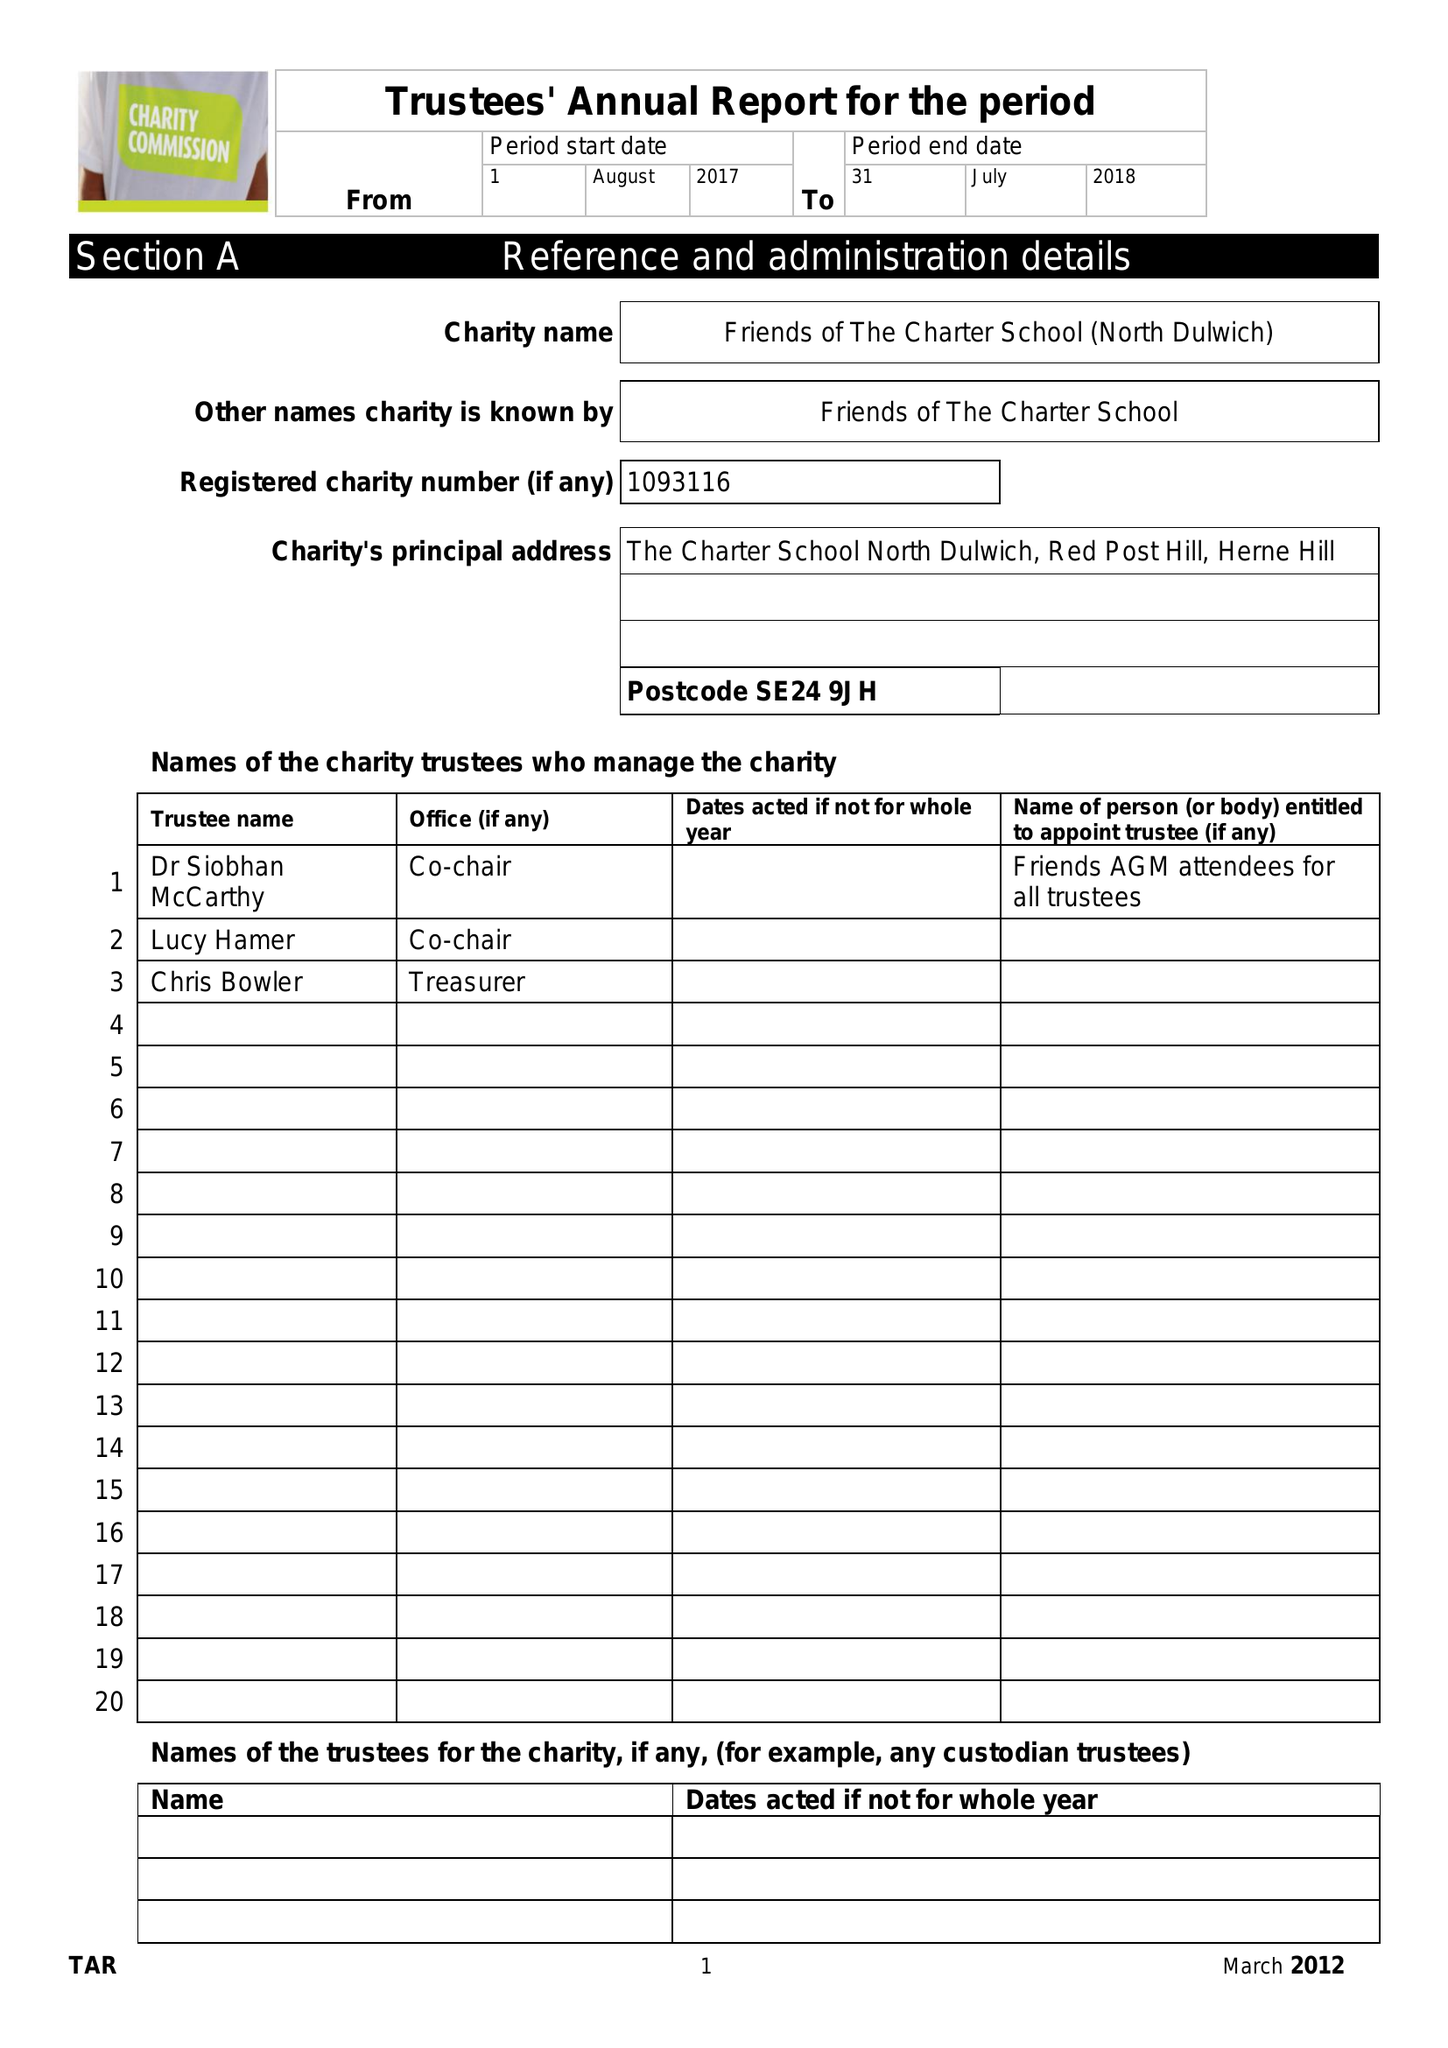What is the value for the address__postcode?
Answer the question using a single word or phrase. SE24 9JH 